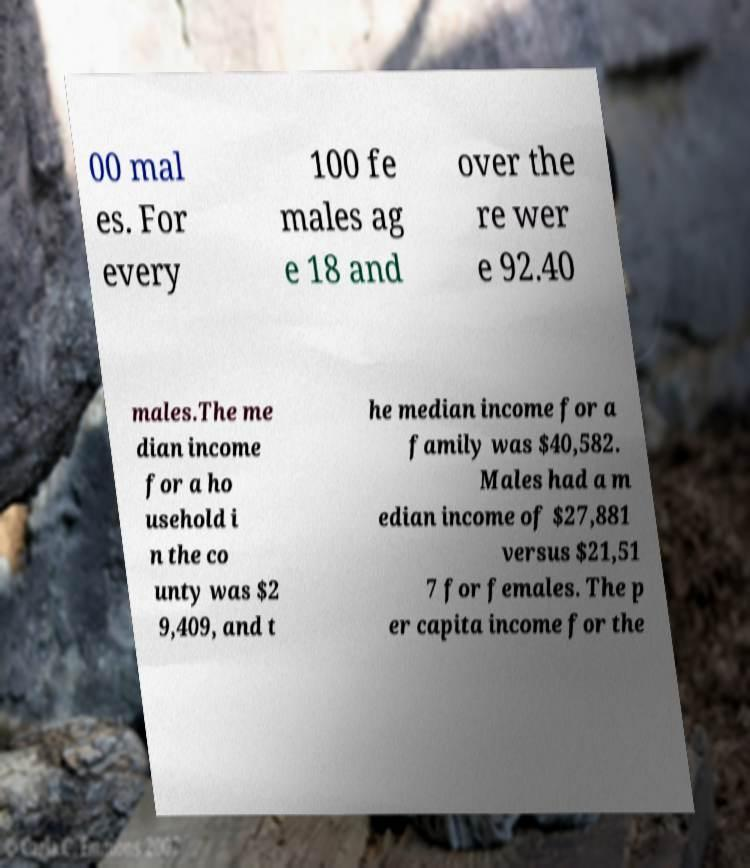Could you extract and type out the text from this image? 00 mal es. For every 100 fe males ag e 18 and over the re wer e 92.40 males.The me dian income for a ho usehold i n the co unty was $2 9,409, and t he median income for a family was $40,582. Males had a m edian income of $27,881 versus $21,51 7 for females. The p er capita income for the 